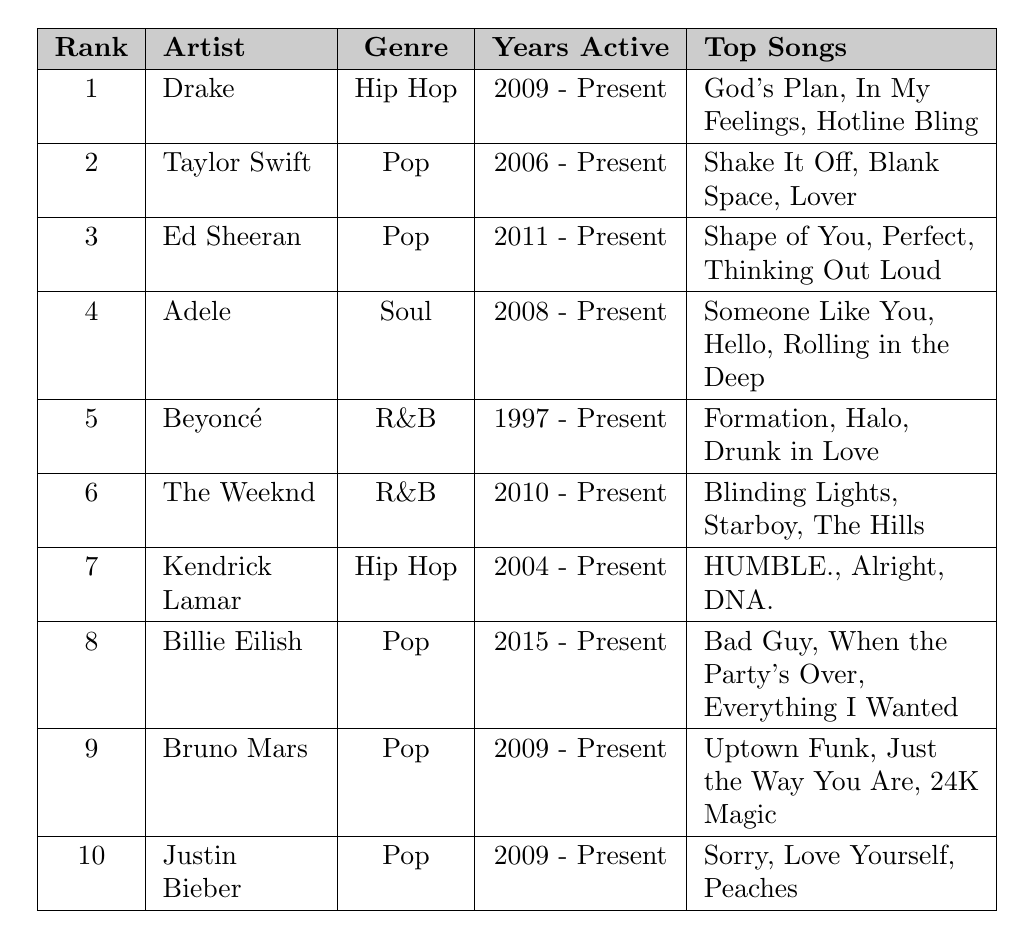What is the genre of the artist ranked 3rd? The artist ranked 3rd in the table is Ed Sheeran, and the table states that his genre is Pop.
Answer: Pop Who has the highest average rank among the artists listed? The artist with the highest average rank is Drake, with an average rank of 1.
Answer: Drake How many artists are in the Hip Hop genre? By counting the rows in the table for the Hip Hop genre, we find that there are 2 artists: Drake and Kendrick Lamar.
Answer: 2 Which artist has been active the longest according to the table? Beyoncé has been active since 1997, which is earlier than any other artist listed in the table.
Answer: Beyoncé What is the average rank of Pop artists in the table? The Pop artists in the table are Taylor Swift, Ed Sheeran, Billie Eilish, Bruno Mars, and Justin Bieber. Their ranks are 2, 3, 8, 9, and 10 respectively. The average rank is (2 + 3 + 8 + 9 + 10) / 5 = 6.4.
Answer: 6.4 Is Adele ranked higher than The Weeknd? Adele's average rank is 4, while The Weeknd's average rank is 6. Since 4 is less than 6, Adele is ranked higher than The Weeknd.
Answer: Yes Which Pop artist has the most recent years active? Billie Eilish is active from 2015 to present, making her the most recently active Pop artist in the table.
Answer: Billie Eilish List the top songs of the artist ranked 5th The artist ranked 5th is Beyoncé, and her top songs listed are Formation, Halo, and Drunk in Love.
Answer: Formation, Halo, Drunk in Love What is the difference in average rank between the highest ranked artist and the lowest ranked artist? The highest ranked artist is Drake with an average rank of 1, and the lowest ranked artist is Justin Bieber with an average rank of 10. The difference is 10 - 1 = 9.
Answer: 9 Do any of the top-ranking artists belong to multiple genres? Each artist listed in the table is assigned to a single genre, so no artist belongs to multiple genres according to the data provided.
Answer: No 